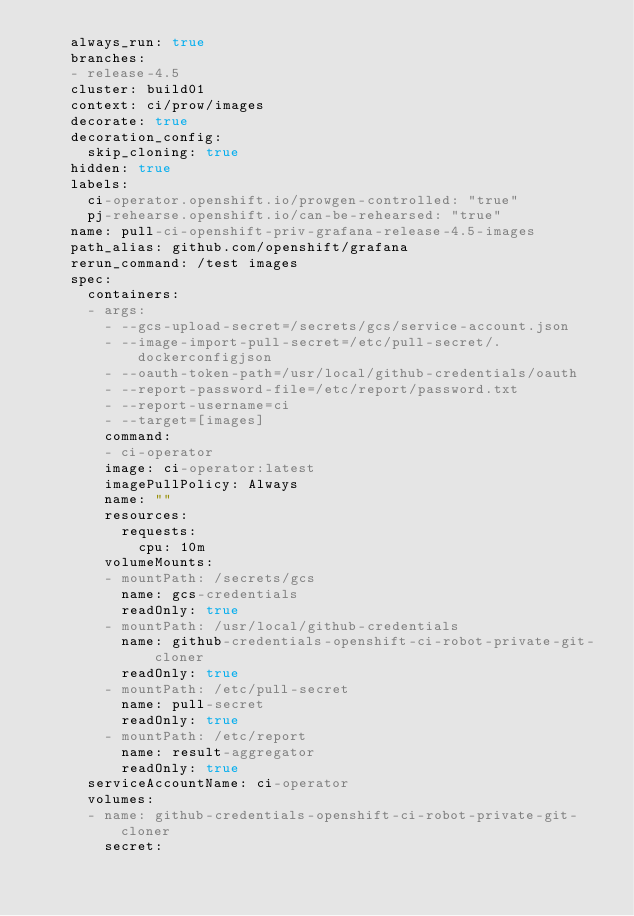Convert code to text. <code><loc_0><loc_0><loc_500><loc_500><_YAML_>    always_run: true
    branches:
    - release-4.5
    cluster: build01
    context: ci/prow/images
    decorate: true
    decoration_config:
      skip_cloning: true
    hidden: true
    labels:
      ci-operator.openshift.io/prowgen-controlled: "true"
      pj-rehearse.openshift.io/can-be-rehearsed: "true"
    name: pull-ci-openshift-priv-grafana-release-4.5-images
    path_alias: github.com/openshift/grafana
    rerun_command: /test images
    spec:
      containers:
      - args:
        - --gcs-upload-secret=/secrets/gcs/service-account.json
        - --image-import-pull-secret=/etc/pull-secret/.dockerconfigjson
        - --oauth-token-path=/usr/local/github-credentials/oauth
        - --report-password-file=/etc/report/password.txt
        - --report-username=ci
        - --target=[images]
        command:
        - ci-operator
        image: ci-operator:latest
        imagePullPolicy: Always
        name: ""
        resources:
          requests:
            cpu: 10m
        volumeMounts:
        - mountPath: /secrets/gcs
          name: gcs-credentials
          readOnly: true
        - mountPath: /usr/local/github-credentials
          name: github-credentials-openshift-ci-robot-private-git-cloner
          readOnly: true
        - mountPath: /etc/pull-secret
          name: pull-secret
          readOnly: true
        - mountPath: /etc/report
          name: result-aggregator
          readOnly: true
      serviceAccountName: ci-operator
      volumes:
      - name: github-credentials-openshift-ci-robot-private-git-cloner
        secret:</code> 